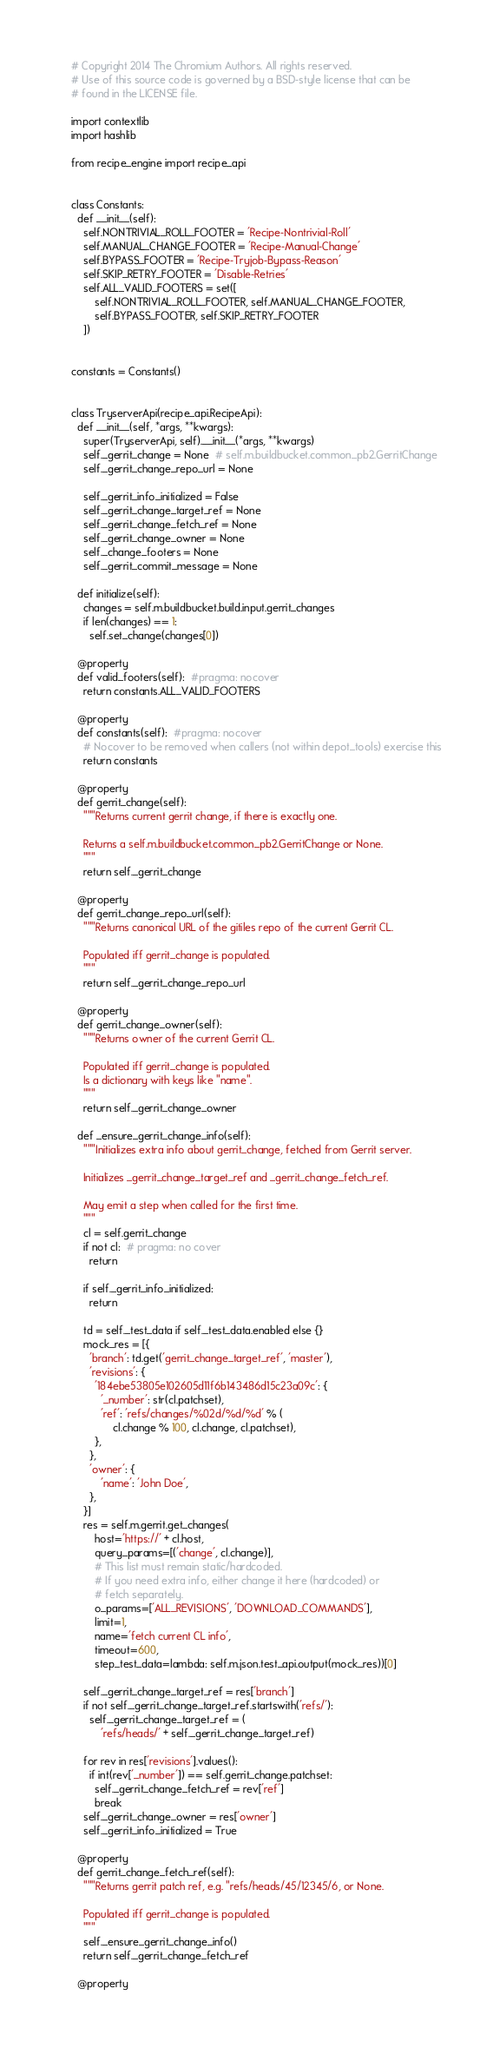Convert code to text. <code><loc_0><loc_0><loc_500><loc_500><_Python_># Copyright 2014 The Chromium Authors. All rights reserved.
# Use of this source code is governed by a BSD-style license that can be
# found in the LICENSE file.

import contextlib
import hashlib

from recipe_engine import recipe_api


class Constants:
  def __init__(self):
    self.NONTRIVIAL_ROLL_FOOTER = 'Recipe-Nontrivial-Roll'
    self.MANUAL_CHANGE_FOOTER = 'Recipe-Manual-Change'
    self.BYPASS_FOOTER = 'Recipe-Tryjob-Bypass-Reason'
    self.SKIP_RETRY_FOOTER = 'Disable-Retries'
    self.ALL_VALID_FOOTERS = set([
        self.NONTRIVIAL_ROLL_FOOTER, self.MANUAL_CHANGE_FOOTER,
        self.BYPASS_FOOTER, self.SKIP_RETRY_FOOTER
    ])


constants = Constants()


class TryserverApi(recipe_api.RecipeApi):
  def __init__(self, *args, **kwargs):
    super(TryserverApi, self).__init__(*args, **kwargs)
    self._gerrit_change = None  # self.m.buildbucket.common_pb2.GerritChange
    self._gerrit_change_repo_url = None

    self._gerrit_info_initialized = False
    self._gerrit_change_target_ref = None
    self._gerrit_change_fetch_ref = None
    self._gerrit_change_owner = None
    self._change_footers = None
    self._gerrit_commit_message = None

  def initialize(self):
    changes = self.m.buildbucket.build.input.gerrit_changes
    if len(changes) == 1:
      self.set_change(changes[0])

  @property
  def valid_footers(self):  #pragma: nocover
    return constants.ALL_VALID_FOOTERS

  @property
  def constants(self):  #pragma: nocover
    # Nocover to be removed when callers (not within depot_tools) exercise this
    return constants

  @property
  def gerrit_change(self):
    """Returns current gerrit change, if there is exactly one.

    Returns a self.m.buildbucket.common_pb2.GerritChange or None.
    """
    return self._gerrit_change

  @property
  def gerrit_change_repo_url(self):
    """Returns canonical URL of the gitiles repo of the current Gerrit CL.

    Populated iff gerrit_change is populated.
    """
    return self._gerrit_change_repo_url

  @property
  def gerrit_change_owner(self):
    """Returns owner of the current Gerrit CL.

    Populated iff gerrit_change is populated.
    Is a dictionary with keys like "name".
    """
    return self._gerrit_change_owner

  def _ensure_gerrit_change_info(self):
    """Initializes extra info about gerrit_change, fetched from Gerrit server.

    Initializes _gerrit_change_target_ref and _gerrit_change_fetch_ref.

    May emit a step when called for the first time.
    """
    cl = self.gerrit_change
    if not cl:  # pragma: no cover
      return

    if self._gerrit_info_initialized:
      return

    td = self._test_data if self._test_data.enabled else {}
    mock_res = [{
      'branch': td.get('gerrit_change_target_ref', 'master'),
      'revisions': {
        '184ebe53805e102605d11f6b143486d15c23a09c': {
          '_number': str(cl.patchset),
          'ref': 'refs/changes/%02d/%d/%d' % (
              cl.change % 100, cl.change, cl.patchset),
        },
      },
      'owner': {
          'name': 'John Doe',
      },
    }]
    res = self.m.gerrit.get_changes(
        host='https://' + cl.host,
        query_params=[('change', cl.change)],
        # This list must remain static/hardcoded.
        # If you need extra info, either change it here (hardcoded) or
        # fetch separately.
        o_params=['ALL_REVISIONS', 'DOWNLOAD_COMMANDS'],
        limit=1,
        name='fetch current CL info',
        timeout=600,
        step_test_data=lambda: self.m.json.test_api.output(mock_res))[0]

    self._gerrit_change_target_ref = res['branch']
    if not self._gerrit_change_target_ref.startswith('refs/'):
      self._gerrit_change_target_ref = (
          'refs/heads/' + self._gerrit_change_target_ref)

    for rev in res['revisions'].values():
      if int(rev['_number']) == self.gerrit_change.patchset:
        self._gerrit_change_fetch_ref = rev['ref']
        break
    self._gerrit_change_owner = res['owner']
    self._gerrit_info_initialized = True

  @property
  def gerrit_change_fetch_ref(self):
    """Returns gerrit patch ref, e.g. "refs/heads/45/12345/6, or None.

    Populated iff gerrit_change is populated.
    """
    self._ensure_gerrit_change_info()
    return self._gerrit_change_fetch_ref

  @property</code> 